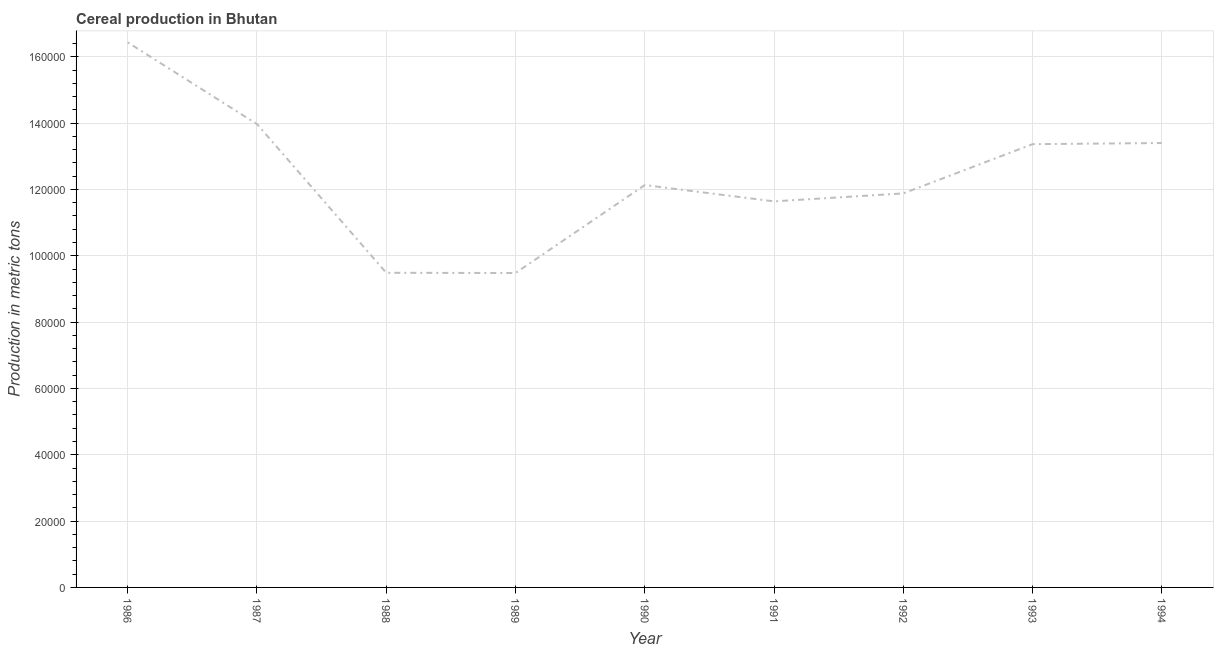What is the cereal production in 1994?
Offer a terse response. 1.34e+05. Across all years, what is the maximum cereal production?
Make the answer very short. 1.64e+05. Across all years, what is the minimum cereal production?
Give a very brief answer. 9.48e+04. In which year was the cereal production maximum?
Provide a short and direct response. 1986. What is the sum of the cereal production?
Provide a succinct answer. 1.12e+06. What is the difference between the cereal production in 1986 and 1990?
Provide a short and direct response. 4.30e+04. What is the average cereal production per year?
Give a very brief answer. 1.24e+05. What is the median cereal production?
Your answer should be very brief. 1.21e+05. Do a majority of the years between 1986 and 1992 (inclusive) have cereal production greater than 76000 metric tons?
Your answer should be compact. Yes. What is the ratio of the cereal production in 1987 to that in 1993?
Your answer should be compact. 1.05. Is the difference between the cereal production in 1989 and 1992 greater than the difference between any two years?
Your answer should be very brief. No. What is the difference between the highest and the second highest cereal production?
Provide a short and direct response. 2.46e+04. Is the sum of the cereal production in 1988 and 1991 greater than the maximum cereal production across all years?
Provide a succinct answer. Yes. What is the difference between the highest and the lowest cereal production?
Keep it short and to the point. 6.96e+04. Does the cereal production monotonically increase over the years?
Your answer should be compact. No. Are the values on the major ticks of Y-axis written in scientific E-notation?
Your answer should be compact. No. Does the graph contain any zero values?
Offer a terse response. No. Does the graph contain grids?
Ensure brevity in your answer.  Yes. What is the title of the graph?
Your answer should be very brief. Cereal production in Bhutan. What is the label or title of the X-axis?
Your response must be concise. Year. What is the label or title of the Y-axis?
Ensure brevity in your answer.  Production in metric tons. What is the Production in metric tons of 1986?
Provide a succinct answer. 1.64e+05. What is the Production in metric tons in 1987?
Provide a short and direct response. 1.40e+05. What is the Production in metric tons of 1988?
Give a very brief answer. 9.49e+04. What is the Production in metric tons in 1989?
Provide a succinct answer. 9.48e+04. What is the Production in metric tons in 1990?
Your response must be concise. 1.21e+05. What is the Production in metric tons in 1991?
Give a very brief answer. 1.16e+05. What is the Production in metric tons in 1992?
Offer a terse response. 1.19e+05. What is the Production in metric tons in 1993?
Provide a succinct answer. 1.34e+05. What is the Production in metric tons of 1994?
Provide a succinct answer. 1.34e+05. What is the difference between the Production in metric tons in 1986 and 1987?
Keep it short and to the point. 2.46e+04. What is the difference between the Production in metric tons in 1986 and 1988?
Give a very brief answer. 6.95e+04. What is the difference between the Production in metric tons in 1986 and 1989?
Make the answer very short. 6.96e+04. What is the difference between the Production in metric tons in 1986 and 1990?
Provide a succinct answer. 4.30e+04. What is the difference between the Production in metric tons in 1986 and 1991?
Make the answer very short. 4.79e+04. What is the difference between the Production in metric tons in 1986 and 1992?
Your response must be concise. 4.55e+04. What is the difference between the Production in metric tons in 1986 and 1993?
Provide a short and direct response. 3.07e+04. What is the difference between the Production in metric tons in 1986 and 1994?
Keep it short and to the point. 3.04e+04. What is the difference between the Production in metric tons in 1987 and 1988?
Make the answer very short. 4.48e+04. What is the difference between the Production in metric tons in 1987 and 1989?
Provide a short and direct response. 4.49e+04. What is the difference between the Production in metric tons in 1987 and 1990?
Offer a terse response. 1.84e+04. What is the difference between the Production in metric tons in 1987 and 1991?
Make the answer very short. 2.33e+04. What is the difference between the Production in metric tons in 1987 and 1992?
Keep it short and to the point. 2.09e+04. What is the difference between the Production in metric tons in 1987 and 1993?
Keep it short and to the point. 6048. What is the difference between the Production in metric tons in 1987 and 1994?
Keep it short and to the point. 5701. What is the difference between the Production in metric tons in 1988 and 1989?
Offer a terse response. 71. What is the difference between the Production in metric tons in 1988 and 1990?
Offer a terse response. -2.64e+04. What is the difference between the Production in metric tons in 1988 and 1991?
Give a very brief answer. -2.15e+04. What is the difference between the Production in metric tons in 1988 and 1992?
Offer a terse response. -2.39e+04. What is the difference between the Production in metric tons in 1988 and 1993?
Your answer should be compact. -3.88e+04. What is the difference between the Production in metric tons in 1988 and 1994?
Your answer should be very brief. -3.91e+04. What is the difference between the Production in metric tons in 1989 and 1990?
Your answer should be compact. -2.65e+04. What is the difference between the Production in metric tons in 1989 and 1991?
Offer a very short reply. -2.16e+04. What is the difference between the Production in metric tons in 1989 and 1992?
Provide a succinct answer. -2.40e+04. What is the difference between the Production in metric tons in 1989 and 1993?
Provide a short and direct response. -3.89e+04. What is the difference between the Production in metric tons in 1989 and 1994?
Provide a short and direct response. -3.92e+04. What is the difference between the Production in metric tons in 1990 and 1991?
Your answer should be very brief. 4915. What is the difference between the Production in metric tons in 1990 and 1992?
Offer a terse response. 2518. What is the difference between the Production in metric tons in 1990 and 1993?
Keep it short and to the point. -1.23e+04. What is the difference between the Production in metric tons in 1990 and 1994?
Your response must be concise. -1.27e+04. What is the difference between the Production in metric tons in 1991 and 1992?
Ensure brevity in your answer.  -2397. What is the difference between the Production in metric tons in 1991 and 1993?
Provide a succinct answer. -1.72e+04. What is the difference between the Production in metric tons in 1991 and 1994?
Provide a succinct answer. -1.76e+04. What is the difference between the Production in metric tons in 1992 and 1993?
Provide a short and direct response. -1.48e+04. What is the difference between the Production in metric tons in 1992 and 1994?
Your answer should be compact. -1.52e+04. What is the difference between the Production in metric tons in 1993 and 1994?
Your answer should be very brief. -347. What is the ratio of the Production in metric tons in 1986 to that in 1987?
Your answer should be very brief. 1.18. What is the ratio of the Production in metric tons in 1986 to that in 1988?
Your answer should be very brief. 1.73. What is the ratio of the Production in metric tons in 1986 to that in 1989?
Give a very brief answer. 1.73. What is the ratio of the Production in metric tons in 1986 to that in 1990?
Your response must be concise. 1.35. What is the ratio of the Production in metric tons in 1986 to that in 1991?
Ensure brevity in your answer.  1.41. What is the ratio of the Production in metric tons in 1986 to that in 1992?
Your answer should be very brief. 1.38. What is the ratio of the Production in metric tons in 1986 to that in 1993?
Keep it short and to the point. 1.23. What is the ratio of the Production in metric tons in 1986 to that in 1994?
Keep it short and to the point. 1.23. What is the ratio of the Production in metric tons in 1987 to that in 1988?
Offer a very short reply. 1.47. What is the ratio of the Production in metric tons in 1987 to that in 1989?
Give a very brief answer. 1.47. What is the ratio of the Production in metric tons in 1987 to that in 1990?
Provide a short and direct response. 1.15. What is the ratio of the Production in metric tons in 1987 to that in 1992?
Your answer should be very brief. 1.18. What is the ratio of the Production in metric tons in 1987 to that in 1993?
Make the answer very short. 1.04. What is the ratio of the Production in metric tons in 1987 to that in 1994?
Provide a short and direct response. 1.04. What is the ratio of the Production in metric tons in 1988 to that in 1990?
Keep it short and to the point. 0.78. What is the ratio of the Production in metric tons in 1988 to that in 1991?
Give a very brief answer. 0.81. What is the ratio of the Production in metric tons in 1988 to that in 1992?
Provide a short and direct response. 0.8. What is the ratio of the Production in metric tons in 1988 to that in 1993?
Provide a succinct answer. 0.71. What is the ratio of the Production in metric tons in 1988 to that in 1994?
Offer a very short reply. 0.71. What is the ratio of the Production in metric tons in 1989 to that in 1990?
Ensure brevity in your answer.  0.78. What is the ratio of the Production in metric tons in 1989 to that in 1991?
Provide a short and direct response. 0.81. What is the ratio of the Production in metric tons in 1989 to that in 1992?
Offer a terse response. 0.8. What is the ratio of the Production in metric tons in 1989 to that in 1993?
Provide a succinct answer. 0.71. What is the ratio of the Production in metric tons in 1989 to that in 1994?
Provide a succinct answer. 0.71. What is the ratio of the Production in metric tons in 1990 to that in 1991?
Your answer should be very brief. 1.04. What is the ratio of the Production in metric tons in 1990 to that in 1992?
Make the answer very short. 1.02. What is the ratio of the Production in metric tons in 1990 to that in 1993?
Make the answer very short. 0.91. What is the ratio of the Production in metric tons in 1990 to that in 1994?
Your response must be concise. 0.91. What is the ratio of the Production in metric tons in 1991 to that in 1992?
Your answer should be compact. 0.98. What is the ratio of the Production in metric tons in 1991 to that in 1993?
Offer a very short reply. 0.87. What is the ratio of the Production in metric tons in 1991 to that in 1994?
Your answer should be compact. 0.87. What is the ratio of the Production in metric tons in 1992 to that in 1993?
Keep it short and to the point. 0.89. What is the ratio of the Production in metric tons in 1992 to that in 1994?
Provide a short and direct response. 0.89. What is the ratio of the Production in metric tons in 1993 to that in 1994?
Your answer should be very brief. 1. 